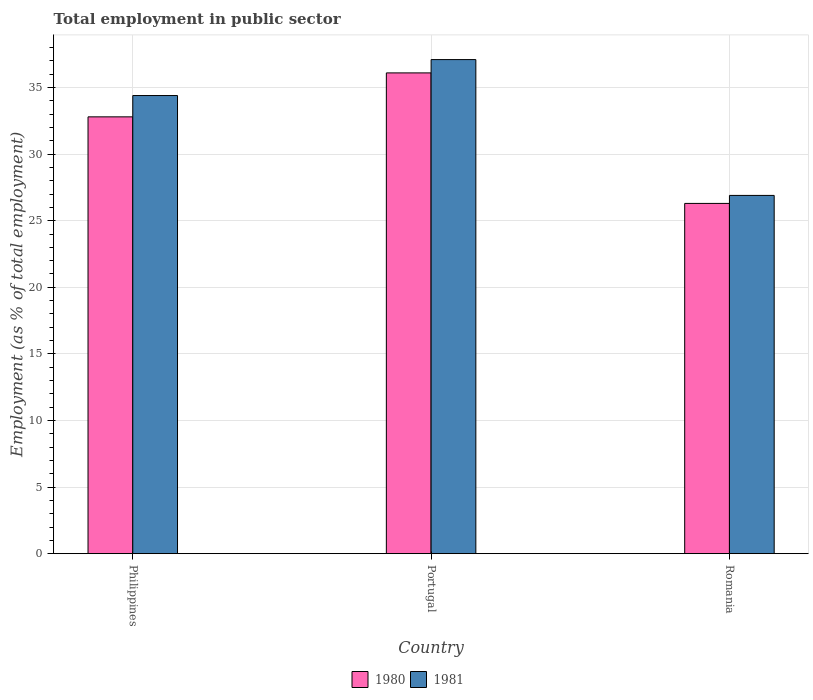Are the number of bars per tick equal to the number of legend labels?
Give a very brief answer. Yes. Are the number of bars on each tick of the X-axis equal?
Keep it short and to the point. Yes. How many bars are there on the 3rd tick from the right?
Provide a short and direct response. 2. What is the label of the 3rd group of bars from the left?
Provide a succinct answer. Romania. In how many cases, is the number of bars for a given country not equal to the number of legend labels?
Offer a terse response. 0. What is the employment in public sector in 1980 in Philippines?
Offer a terse response. 32.8. Across all countries, what is the maximum employment in public sector in 1980?
Offer a terse response. 36.1. Across all countries, what is the minimum employment in public sector in 1981?
Your answer should be very brief. 26.9. In which country was the employment in public sector in 1981 minimum?
Your answer should be compact. Romania. What is the total employment in public sector in 1981 in the graph?
Your response must be concise. 98.4. What is the difference between the employment in public sector in 1981 in Portugal and that in Romania?
Ensure brevity in your answer.  10.2. What is the difference between the employment in public sector in 1981 in Portugal and the employment in public sector in 1980 in Romania?
Ensure brevity in your answer.  10.8. What is the average employment in public sector in 1980 per country?
Provide a succinct answer. 31.73. What is the difference between the employment in public sector of/in 1980 and employment in public sector of/in 1981 in Romania?
Your response must be concise. -0.6. In how many countries, is the employment in public sector in 1981 greater than 25 %?
Your answer should be very brief. 3. What is the ratio of the employment in public sector in 1980 in Philippines to that in Romania?
Provide a short and direct response. 1.25. What is the difference between the highest and the second highest employment in public sector in 1981?
Make the answer very short. 7.5. What is the difference between the highest and the lowest employment in public sector in 1981?
Provide a short and direct response. 10.2. In how many countries, is the employment in public sector in 1980 greater than the average employment in public sector in 1980 taken over all countries?
Provide a short and direct response. 2. How many countries are there in the graph?
Offer a terse response. 3. What is the difference between two consecutive major ticks on the Y-axis?
Ensure brevity in your answer.  5. Does the graph contain any zero values?
Offer a very short reply. No. What is the title of the graph?
Make the answer very short. Total employment in public sector. What is the label or title of the X-axis?
Give a very brief answer. Country. What is the label or title of the Y-axis?
Keep it short and to the point. Employment (as % of total employment). What is the Employment (as % of total employment) in 1980 in Philippines?
Keep it short and to the point. 32.8. What is the Employment (as % of total employment) in 1981 in Philippines?
Offer a terse response. 34.4. What is the Employment (as % of total employment) in 1980 in Portugal?
Keep it short and to the point. 36.1. What is the Employment (as % of total employment) in 1981 in Portugal?
Your response must be concise. 37.1. What is the Employment (as % of total employment) in 1980 in Romania?
Keep it short and to the point. 26.3. What is the Employment (as % of total employment) of 1981 in Romania?
Provide a short and direct response. 26.9. Across all countries, what is the maximum Employment (as % of total employment) of 1980?
Ensure brevity in your answer.  36.1. Across all countries, what is the maximum Employment (as % of total employment) of 1981?
Keep it short and to the point. 37.1. Across all countries, what is the minimum Employment (as % of total employment) of 1980?
Make the answer very short. 26.3. Across all countries, what is the minimum Employment (as % of total employment) in 1981?
Offer a terse response. 26.9. What is the total Employment (as % of total employment) in 1980 in the graph?
Keep it short and to the point. 95.2. What is the total Employment (as % of total employment) in 1981 in the graph?
Provide a succinct answer. 98.4. What is the difference between the Employment (as % of total employment) in 1981 in Philippines and that in Romania?
Keep it short and to the point. 7.5. What is the average Employment (as % of total employment) in 1980 per country?
Ensure brevity in your answer.  31.73. What is the average Employment (as % of total employment) of 1981 per country?
Provide a short and direct response. 32.8. What is the difference between the Employment (as % of total employment) in 1980 and Employment (as % of total employment) in 1981 in Philippines?
Offer a terse response. -1.6. What is the ratio of the Employment (as % of total employment) in 1980 in Philippines to that in Portugal?
Make the answer very short. 0.91. What is the ratio of the Employment (as % of total employment) of 1981 in Philippines to that in Portugal?
Provide a succinct answer. 0.93. What is the ratio of the Employment (as % of total employment) in 1980 in Philippines to that in Romania?
Your response must be concise. 1.25. What is the ratio of the Employment (as % of total employment) of 1981 in Philippines to that in Romania?
Your answer should be very brief. 1.28. What is the ratio of the Employment (as % of total employment) in 1980 in Portugal to that in Romania?
Provide a succinct answer. 1.37. What is the ratio of the Employment (as % of total employment) of 1981 in Portugal to that in Romania?
Keep it short and to the point. 1.38. What is the difference between the highest and the second highest Employment (as % of total employment) of 1980?
Make the answer very short. 3.3. 